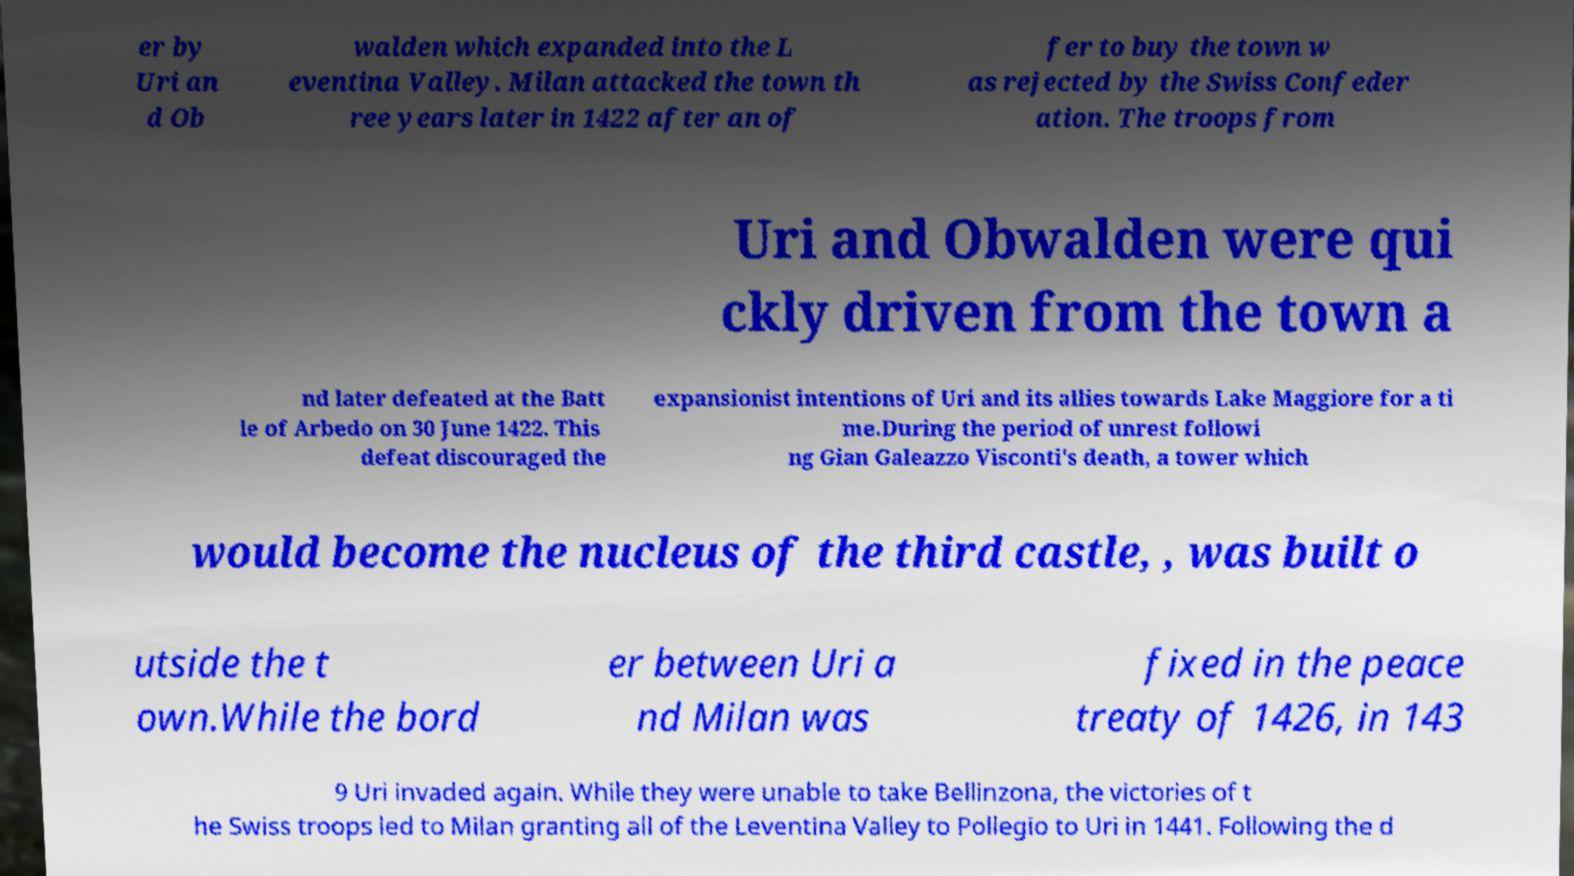Can you read and provide the text displayed in the image?This photo seems to have some interesting text. Can you extract and type it out for me? er by Uri an d Ob walden which expanded into the L eventina Valley. Milan attacked the town th ree years later in 1422 after an of fer to buy the town w as rejected by the Swiss Confeder ation. The troops from Uri and Obwalden were qui ckly driven from the town a nd later defeated at the Batt le of Arbedo on 30 June 1422. This defeat discouraged the expansionist intentions of Uri and its allies towards Lake Maggiore for a ti me.During the period of unrest followi ng Gian Galeazzo Visconti's death, a tower which would become the nucleus of the third castle, , was built o utside the t own.While the bord er between Uri a nd Milan was fixed in the peace treaty of 1426, in 143 9 Uri invaded again. While they were unable to take Bellinzona, the victories of t he Swiss troops led to Milan granting all of the Leventina Valley to Pollegio to Uri in 1441. Following the d 